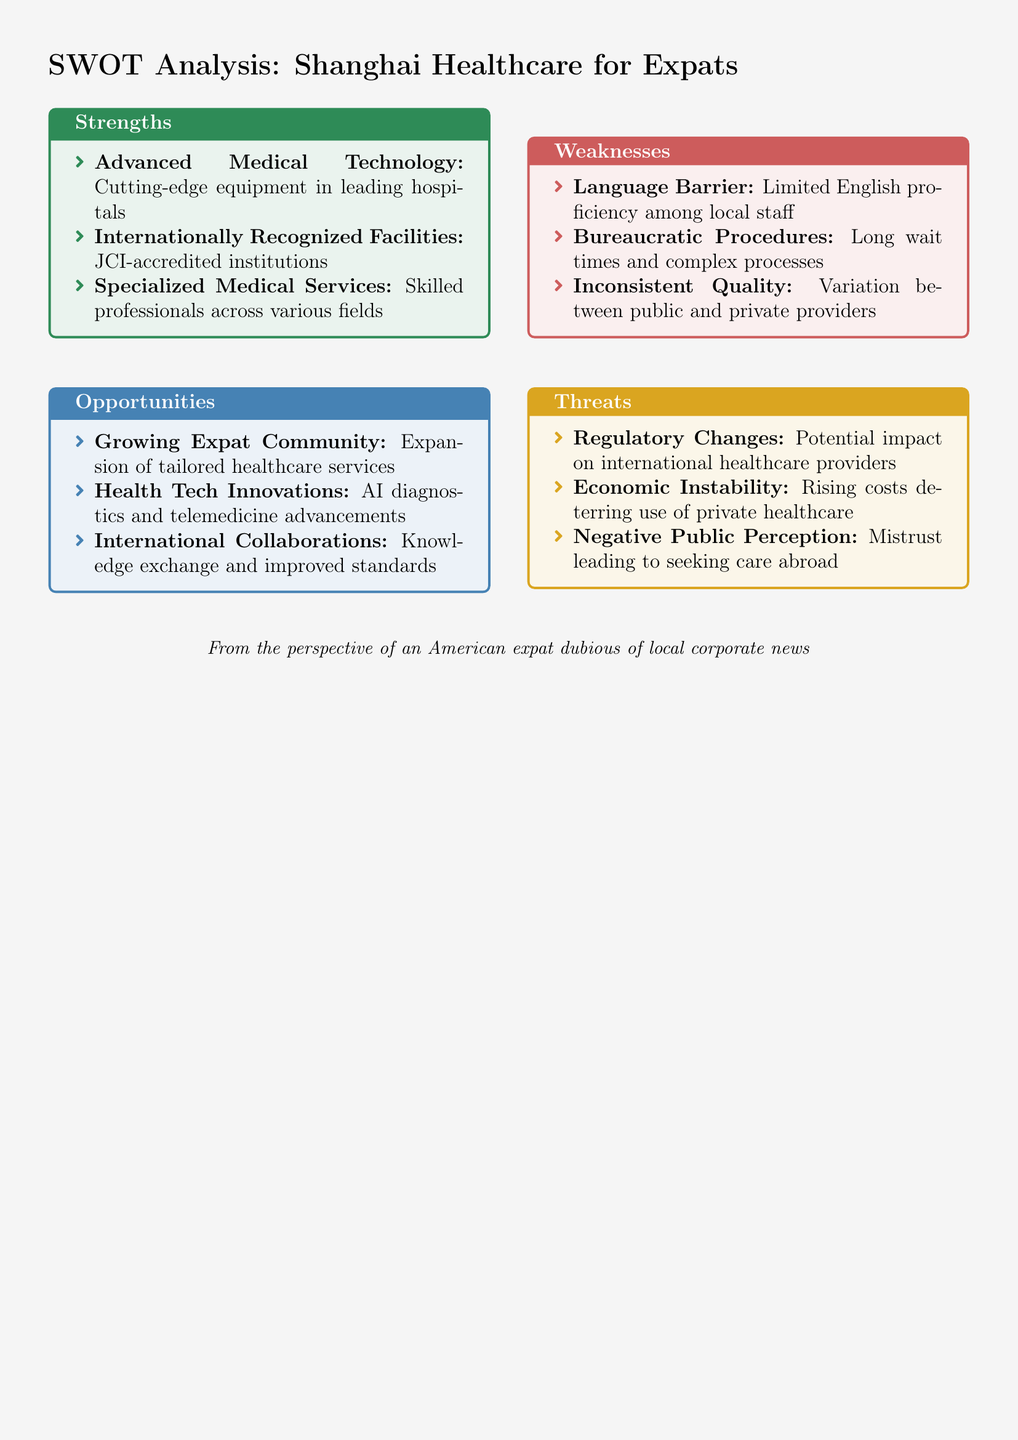what are three strengths of Shanghai healthcare for expats? The strengths listed in the document include "Advanced Medical Technology," "Internationally Recognized Facilities," and "Specialized Medical Services."
Answer: Advanced Medical Technology, Internationally Recognized Facilities, Specialized Medical Services what is a significant opportunity for the local healthcare services? The document mentions "Growing Expat Community" as an opportunity that may lead to the expansion of tailored healthcare services.
Answer: Growing Expat Community what is one weakness related to language in local healthcare services? The document states that a weakness is the "Language Barrier," which refers to limited English proficiency among local staff.
Answer: Language Barrier name one threat to local healthcare providers mentioned in the document. The document identifies "Regulatory Changes" as a threat that could impact international healthcare providers.
Answer: Regulatory Changes how many strengths are listed in the document? There are three strengths listed in the strengths section of the SWOT analysis.
Answer: 3 what medical technology is highlighted as a strength? The document emphasizes "Advanced Medical Technology," as a strength of the local healthcare services for expats.
Answer: Advanced Medical Technology what are the two types of healthcare innovations mentioned as opportunities? The document highlights "Health Tech Innovations" that include AI diagnostics and telemedicine advancements as trends in opportunities.
Answer: Health Tech Innovations which medical accreditation is mentioned to signify quality in facilities? The document mentions "JCI-accredited institutions" as a signifier of quality in healthcare facilities.
Answer: JCI-accredited institutions 